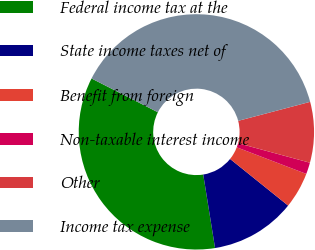Convert chart. <chart><loc_0><loc_0><loc_500><loc_500><pie_chart><fcel>Federal income tax at the<fcel>State income taxes net of<fcel>Benefit from foreign<fcel>Non-taxable interest income<fcel>Other<fcel>Income tax expense<nl><fcel>35.03%<fcel>11.69%<fcel>4.96%<fcel>1.59%<fcel>8.33%<fcel>38.39%<nl></chart> 